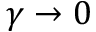Convert formula to latex. <formula><loc_0><loc_0><loc_500><loc_500>\gamma \to 0</formula> 